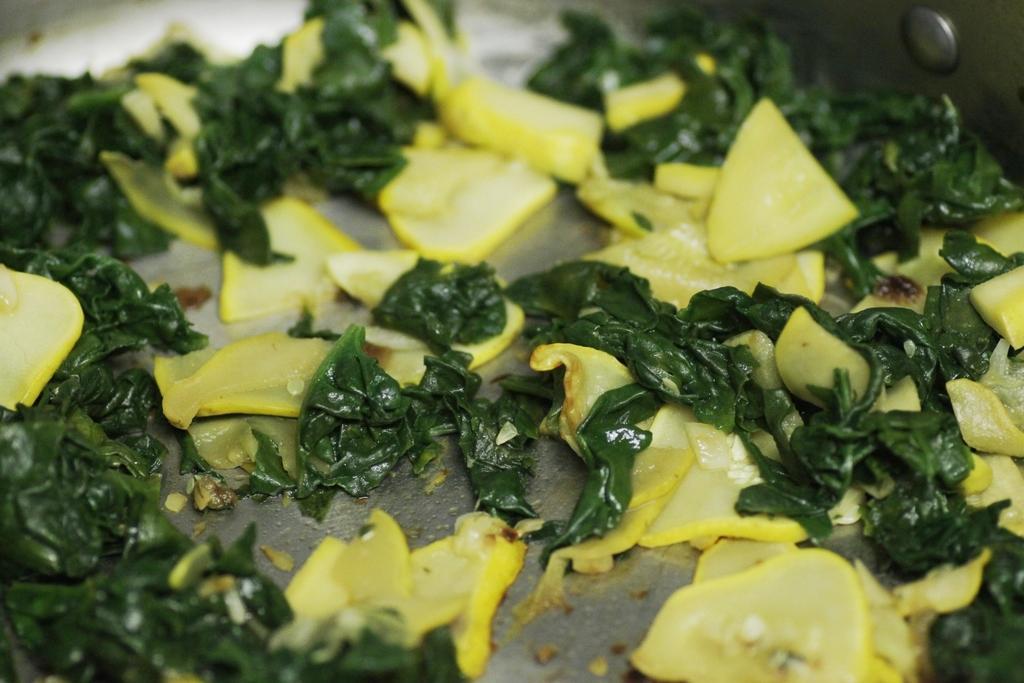Please provide a concise description of this image. In this image I can see the food and the food is in yellow and green color. 